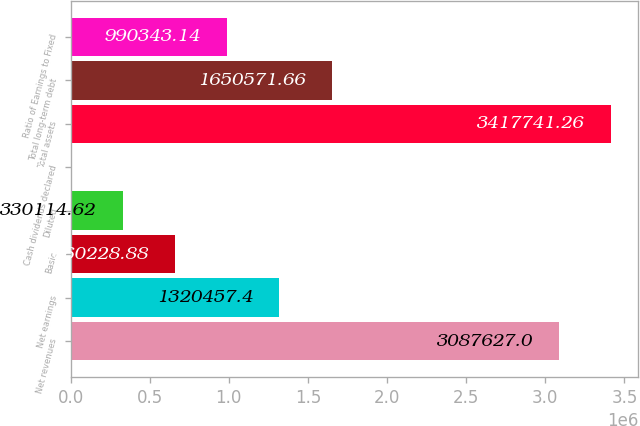<chart> <loc_0><loc_0><loc_500><loc_500><bar_chart><fcel>Net revenues<fcel>Net earnings<fcel>Basic<fcel>Diluted<fcel>Cash dividends declared<fcel>Total assets<fcel>Total long-term debt<fcel>Ratio of Earnings to Fixed<nl><fcel>3.08763e+06<fcel>1.32046e+06<fcel>660229<fcel>330115<fcel>0.36<fcel>3.41774e+06<fcel>1.65057e+06<fcel>990343<nl></chart> 